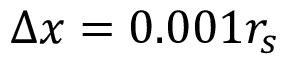<formula> <loc_0><loc_0><loc_500><loc_500>\Delta x = 0 . 0 0 1 r _ { s }</formula> 